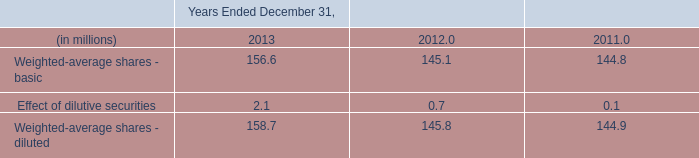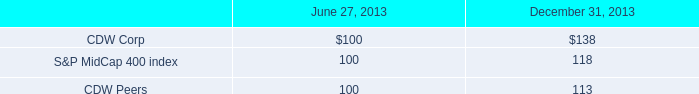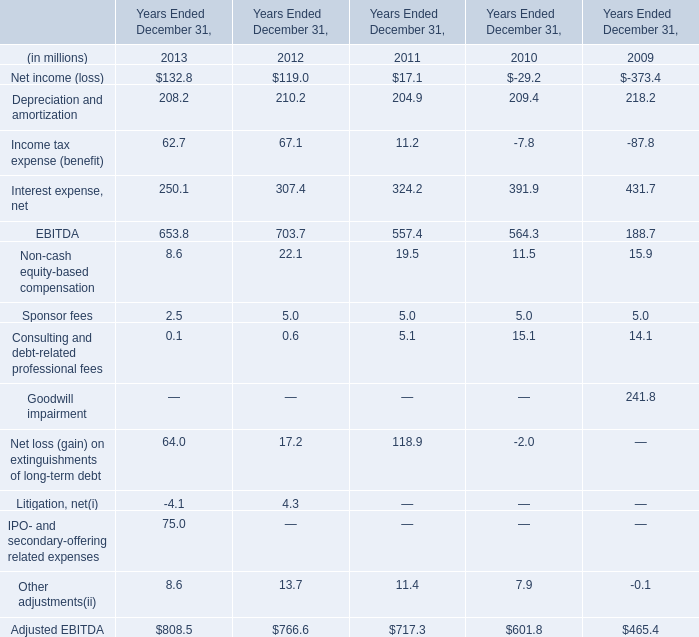What is the growing rate of EBITDA in the year with the most Income tax expense (benefit)? 
Computations: ((703.7 - 653.8) / 703.7)
Answer: 0.07091. 